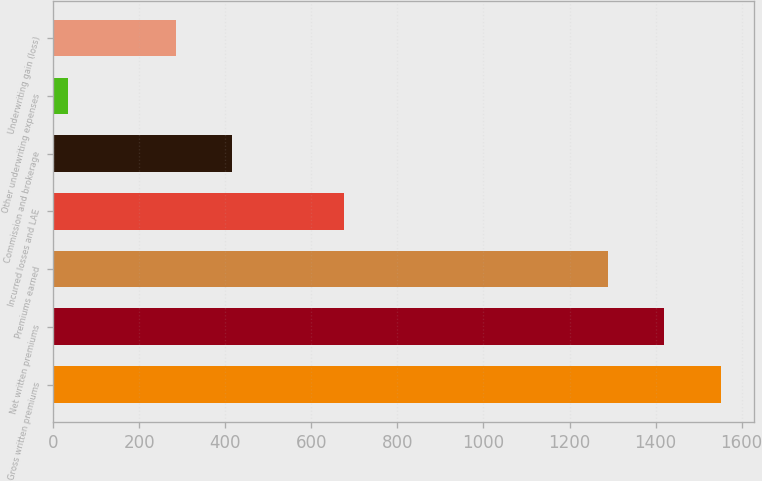Convert chart. <chart><loc_0><loc_0><loc_500><loc_500><bar_chart><fcel>Gross written premiums<fcel>Net written premiums<fcel>Premiums earned<fcel>Incurred losses and LAE<fcel>Commission and brokerage<fcel>Other underwriting expenses<fcel>Underwriting gain (loss)<nl><fcel>1551.68<fcel>1420.49<fcel>1289.3<fcel>675.4<fcel>415.39<fcel>33.9<fcel>284.2<nl></chart> 